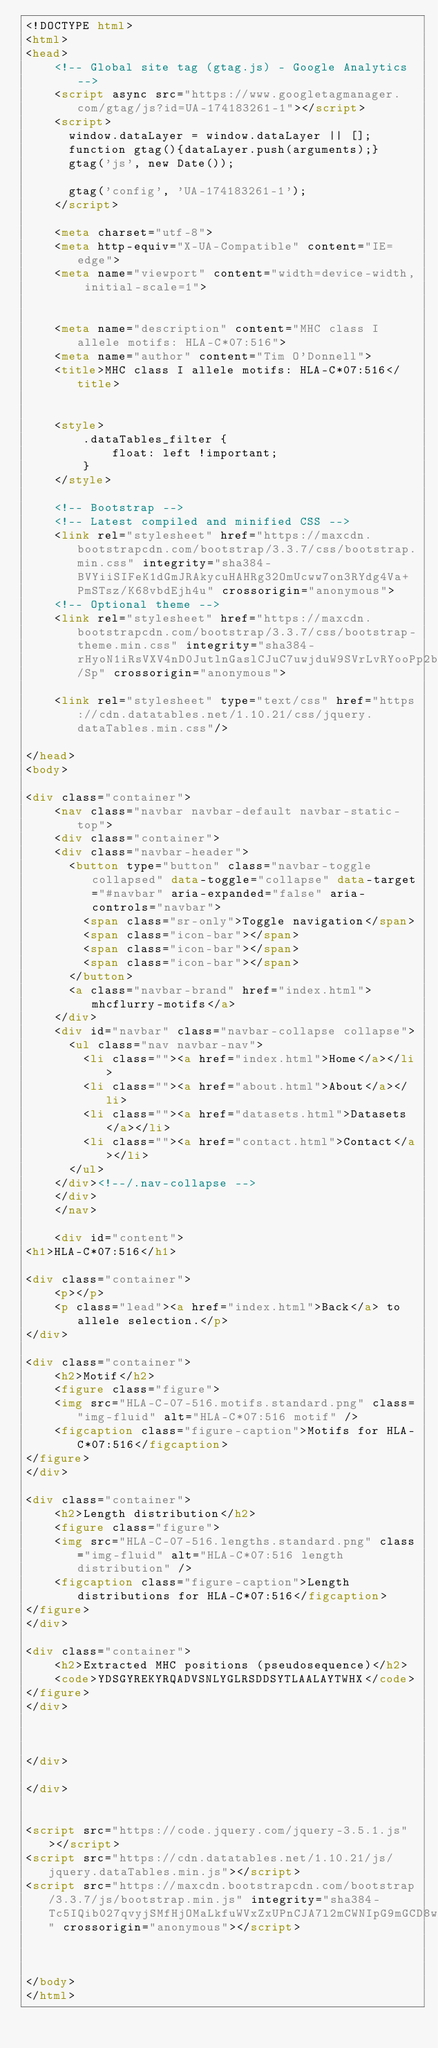Convert code to text. <code><loc_0><loc_0><loc_500><loc_500><_HTML_><!DOCTYPE html>
<html>
<head>
    <!-- Global site tag (gtag.js) - Google Analytics -->
    <script async src="https://www.googletagmanager.com/gtag/js?id=UA-174183261-1"></script>
    <script>
      window.dataLayer = window.dataLayer || [];
      function gtag(){dataLayer.push(arguments);}
      gtag('js', new Date());

      gtag('config', 'UA-174183261-1');
    </script>

    <meta charset="utf-8">
    <meta http-equiv="X-UA-Compatible" content="IE=edge">
    <meta name="viewport" content="width=device-width, initial-scale=1">

    
    <meta name="description" content="MHC class I allele motifs: HLA-C*07:516">
    <meta name="author" content="Tim O'Donnell">
    <title>MHC class I allele motifs: HLA-C*07:516</title>
    

    <style>
        .dataTables_filter {
            float: left !important;
        }
    </style>

    <!-- Bootstrap -->
    <!-- Latest compiled and minified CSS -->
    <link rel="stylesheet" href="https://maxcdn.bootstrapcdn.com/bootstrap/3.3.7/css/bootstrap.min.css" integrity="sha384-BVYiiSIFeK1dGmJRAkycuHAHRg32OmUcww7on3RYdg4Va+PmSTsz/K68vbdEjh4u" crossorigin="anonymous">
    <!-- Optional theme -->
    <link rel="stylesheet" href="https://maxcdn.bootstrapcdn.com/bootstrap/3.3.7/css/bootstrap-theme.min.css" integrity="sha384-rHyoN1iRsVXV4nD0JutlnGaslCJuC7uwjduW9SVrLvRYooPp2bWYgmgJQIXwl/Sp" crossorigin="anonymous">

    <link rel="stylesheet" type="text/css" href="https://cdn.datatables.net/1.10.21/css/jquery.dataTables.min.css"/>

</head>
<body>

<div class="container">
    <nav class="navbar navbar-default navbar-static-top">
    <div class="container">
    <div class="navbar-header">
      <button type="button" class="navbar-toggle collapsed" data-toggle="collapse" data-target="#navbar" aria-expanded="false" aria-controls="navbar">
        <span class="sr-only">Toggle navigation</span>
        <span class="icon-bar"></span>
        <span class="icon-bar"></span>
        <span class="icon-bar"></span>
      </button>
      <a class="navbar-brand" href="index.html">mhcflurry-motifs</a>
    </div>
    <div id="navbar" class="navbar-collapse collapse">
      <ul class="nav navbar-nav">
        <li class=""><a href="index.html">Home</a></li>
        <li class=""><a href="about.html">About</a></li>
        <li class=""><a href="datasets.html">Datasets</a></li>
        <li class=""><a href="contact.html">Contact</a></li>
      </ul>
    </div><!--/.nav-collapse -->
    </div>
    </nav>

    <div id="content">
<h1>HLA-C*07:516</h1>

<div class="container">
    <p></p>
    <p class="lead"><a href="index.html">Back</a> to allele selection.</p>
</div>

<div class="container">
    <h2>Motif</h2>
    <figure class="figure">
    <img src="HLA-C-07-516.motifs.standard.png" class="img-fluid" alt="HLA-C*07:516 motif" />
    <figcaption class="figure-caption">Motifs for HLA-C*07:516</figcaption>
</figure>
</div>

<div class="container">
    <h2>Length distribution</h2>
    <figure class="figure">
    <img src="HLA-C-07-516.lengths.standard.png" class="img-fluid" alt="HLA-C*07:516 length distribution" />
    <figcaption class="figure-caption">Length distributions for HLA-C*07:516</figcaption>
</figure>
</div>

<div class="container">
    <h2>Extracted MHC positions (pseudosequence)</h2>
    <code>YDSGYREKYRQADVSNLYGLRSDDSYTLAALAYTWHX</code>
</figure>
</div>



</div>

</div>


<script src="https://code.jquery.com/jquery-3.5.1.js"></script>
<script src="https://cdn.datatables.net/1.10.21/js/jquery.dataTables.min.js"></script>
<script src="https://maxcdn.bootstrapcdn.com/bootstrap/3.3.7/js/bootstrap.min.js" integrity="sha384-Tc5IQib027qvyjSMfHjOMaLkfuWVxZxUPnCJA7l2mCWNIpG9mGCD8wGNIcPD7Txa" crossorigin="anonymous"></script>



</body>
</html></code> 